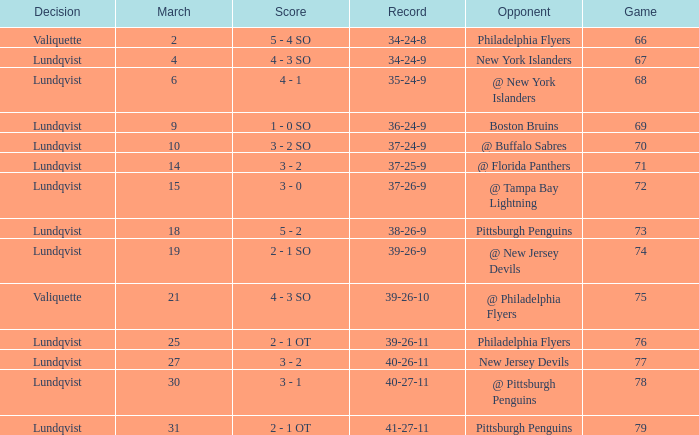Which opponent's march was 31? Pittsburgh Penguins. 